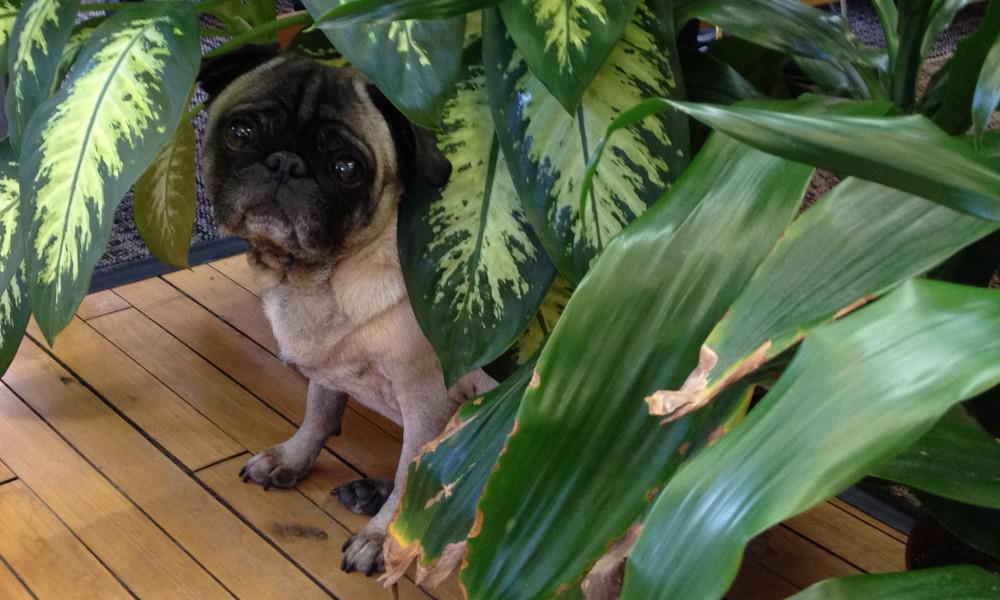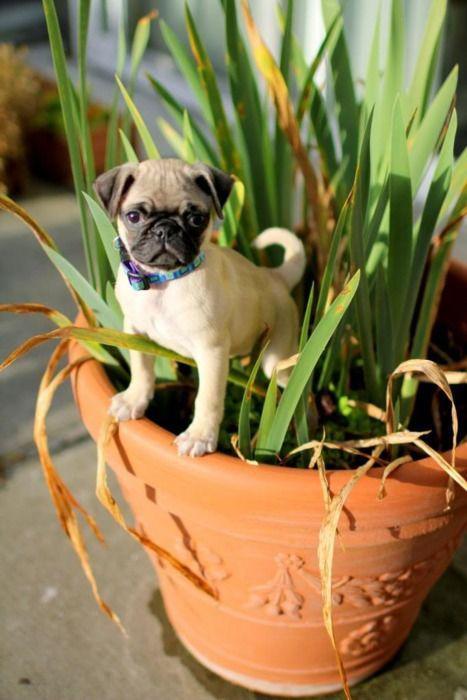The first image is the image on the left, the second image is the image on the right. Evaluate the accuracy of this statement regarding the images: "I at least one image there is a pug looking straight forward wearing a costume that circles its head.". Is it true? Answer yes or no. No. The first image is the image on the left, the second image is the image on the right. Evaluate the accuracy of this statement regarding the images: "Each image includes one beige pug with a dark muzzle, who is surrounded by some type of green foliage.". Is it true? Answer yes or no. Yes. 